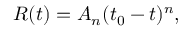Convert formula to latex. <formula><loc_0><loc_0><loc_500><loc_500>R ( t ) = A _ { n } ( t _ { 0 } - t ) ^ { n } ,</formula> 